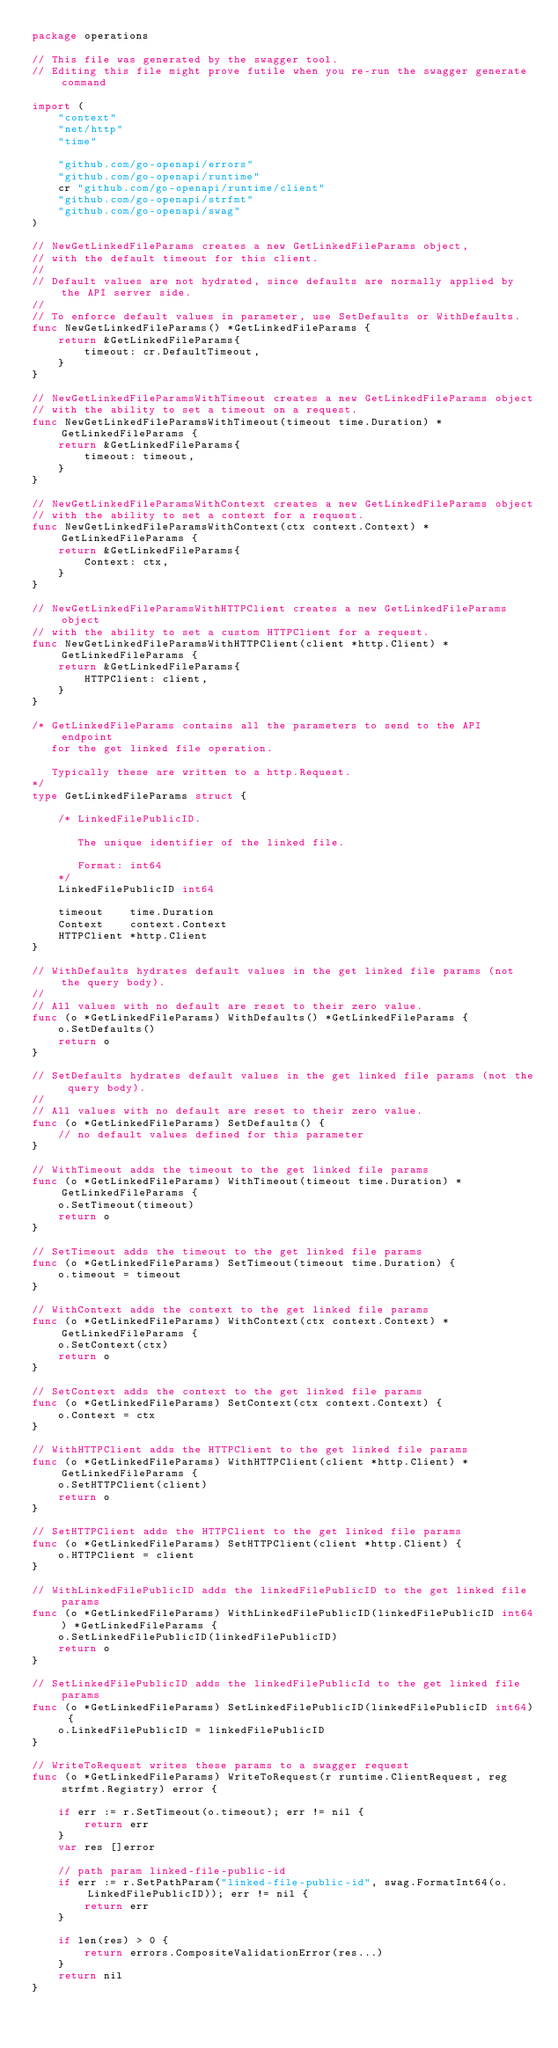<code> <loc_0><loc_0><loc_500><loc_500><_Go_>package operations

// This file was generated by the swagger tool.
// Editing this file might prove futile when you re-run the swagger generate command

import (
	"context"
	"net/http"
	"time"

	"github.com/go-openapi/errors"
	"github.com/go-openapi/runtime"
	cr "github.com/go-openapi/runtime/client"
	"github.com/go-openapi/strfmt"
	"github.com/go-openapi/swag"
)

// NewGetLinkedFileParams creates a new GetLinkedFileParams object,
// with the default timeout for this client.
//
// Default values are not hydrated, since defaults are normally applied by the API server side.
//
// To enforce default values in parameter, use SetDefaults or WithDefaults.
func NewGetLinkedFileParams() *GetLinkedFileParams {
	return &GetLinkedFileParams{
		timeout: cr.DefaultTimeout,
	}
}

// NewGetLinkedFileParamsWithTimeout creates a new GetLinkedFileParams object
// with the ability to set a timeout on a request.
func NewGetLinkedFileParamsWithTimeout(timeout time.Duration) *GetLinkedFileParams {
	return &GetLinkedFileParams{
		timeout: timeout,
	}
}

// NewGetLinkedFileParamsWithContext creates a new GetLinkedFileParams object
// with the ability to set a context for a request.
func NewGetLinkedFileParamsWithContext(ctx context.Context) *GetLinkedFileParams {
	return &GetLinkedFileParams{
		Context: ctx,
	}
}

// NewGetLinkedFileParamsWithHTTPClient creates a new GetLinkedFileParams object
// with the ability to set a custom HTTPClient for a request.
func NewGetLinkedFileParamsWithHTTPClient(client *http.Client) *GetLinkedFileParams {
	return &GetLinkedFileParams{
		HTTPClient: client,
	}
}

/* GetLinkedFileParams contains all the parameters to send to the API endpoint
   for the get linked file operation.

   Typically these are written to a http.Request.
*/
type GetLinkedFileParams struct {

	/* LinkedFilePublicID.

	   The unique identifier of the linked file.

	   Format: int64
	*/
	LinkedFilePublicID int64

	timeout    time.Duration
	Context    context.Context
	HTTPClient *http.Client
}

// WithDefaults hydrates default values in the get linked file params (not the query body).
//
// All values with no default are reset to their zero value.
func (o *GetLinkedFileParams) WithDefaults() *GetLinkedFileParams {
	o.SetDefaults()
	return o
}

// SetDefaults hydrates default values in the get linked file params (not the query body).
//
// All values with no default are reset to their zero value.
func (o *GetLinkedFileParams) SetDefaults() {
	// no default values defined for this parameter
}

// WithTimeout adds the timeout to the get linked file params
func (o *GetLinkedFileParams) WithTimeout(timeout time.Duration) *GetLinkedFileParams {
	o.SetTimeout(timeout)
	return o
}

// SetTimeout adds the timeout to the get linked file params
func (o *GetLinkedFileParams) SetTimeout(timeout time.Duration) {
	o.timeout = timeout
}

// WithContext adds the context to the get linked file params
func (o *GetLinkedFileParams) WithContext(ctx context.Context) *GetLinkedFileParams {
	o.SetContext(ctx)
	return o
}

// SetContext adds the context to the get linked file params
func (o *GetLinkedFileParams) SetContext(ctx context.Context) {
	o.Context = ctx
}

// WithHTTPClient adds the HTTPClient to the get linked file params
func (o *GetLinkedFileParams) WithHTTPClient(client *http.Client) *GetLinkedFileParams {
	o.SetHTTPClient(client)
	return o
}

// SetHTTPClient adds the HTTPClient to the get linked file params
func (o *GetLinkedFileParams) SetHTTPClient(client *http.Client) {
	o.HTTPClient = client
}

// WithLinkedFilePublicID adds the linkedFilePublicID to the get linked file params
func (o *GetLinkedFileParams) WithLinkedFilePublicID(linkedFilePublicID int64) *GetLinkedFileParams {
	o.SetLinkedFilePublicID(linkedFilePublicID)
	return o
}

// SetLinkedFilePublicID adds the linkedFilePublicId to the get linked file params
func (o *GetLinkedFileParams) SetLinkedFilePublicID(linkedFilePublicID int64) {
	o.LinkedFilePublicID = linkedFilePublicID
}

// WriteToRequest writes these params to a swagger request
func (o *GetLinkedFileParams) WriteToRequest(r runtime.ClientRequest, reg strfmt.Registry) error {

	if err := r.SetTimeout(o.timeout); err != nil {
		return err
	}
	var res []error

	// path param linked-file-public-id
	if err := r.SetPathParam("linked-file-public-id", swag.FormatInt64(o.LinkedFilePublicID)); err != nil {
		return err
	}

	if len(res) > 0 {
		return errors.CompositeValidationError(res...)
	}
	return nil
}
</code> 